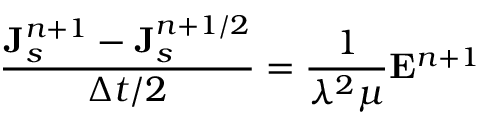<formula> <loc_0><loc_0><loc_500><loc_500>\frac { { J } _ { s } ^ { n + 1 } - { J } _ { s } ^ { n + 1 / 2 } } { \Delta t / 2 } = \frac { 1 } { \lambda ^ { 2 } \mu } { E } ^ { n + 1 }</formula> 